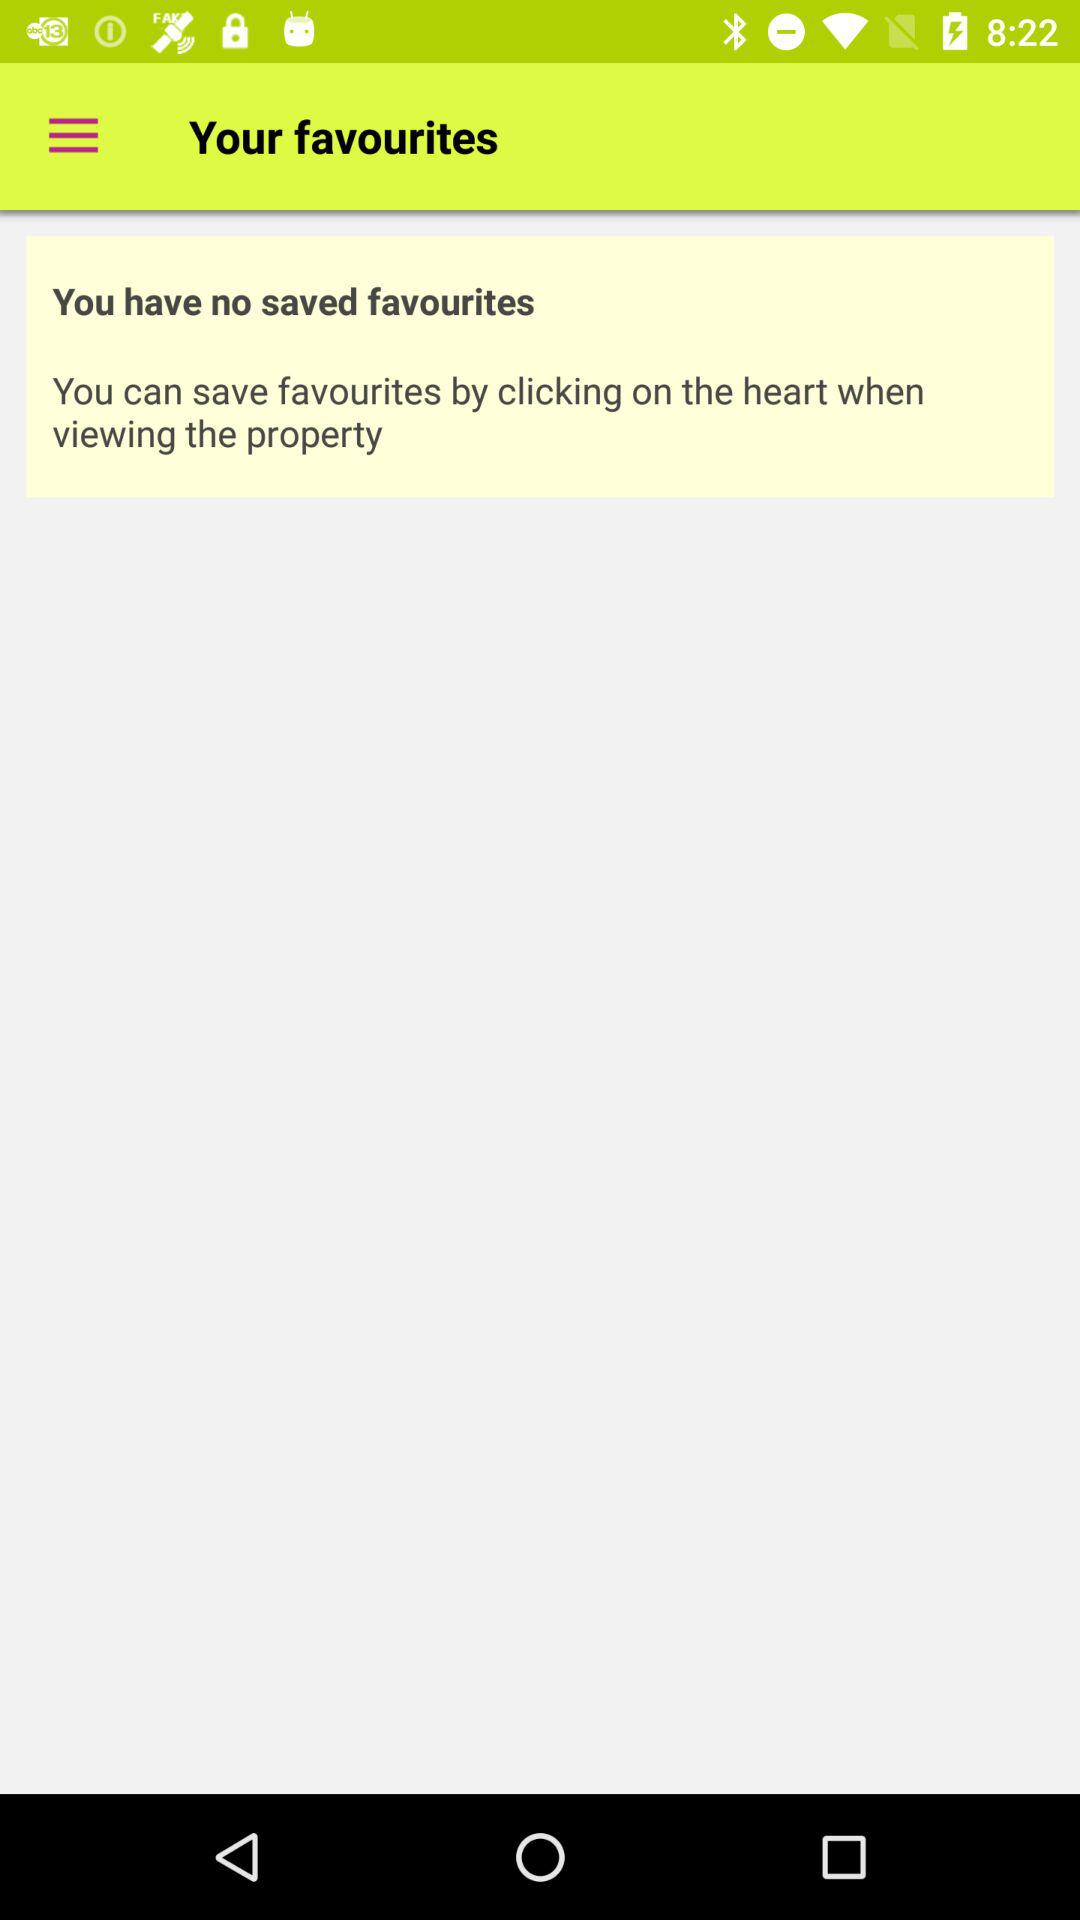How many saved favourites do I have?
Answer the question using a single word or phrase. 0 